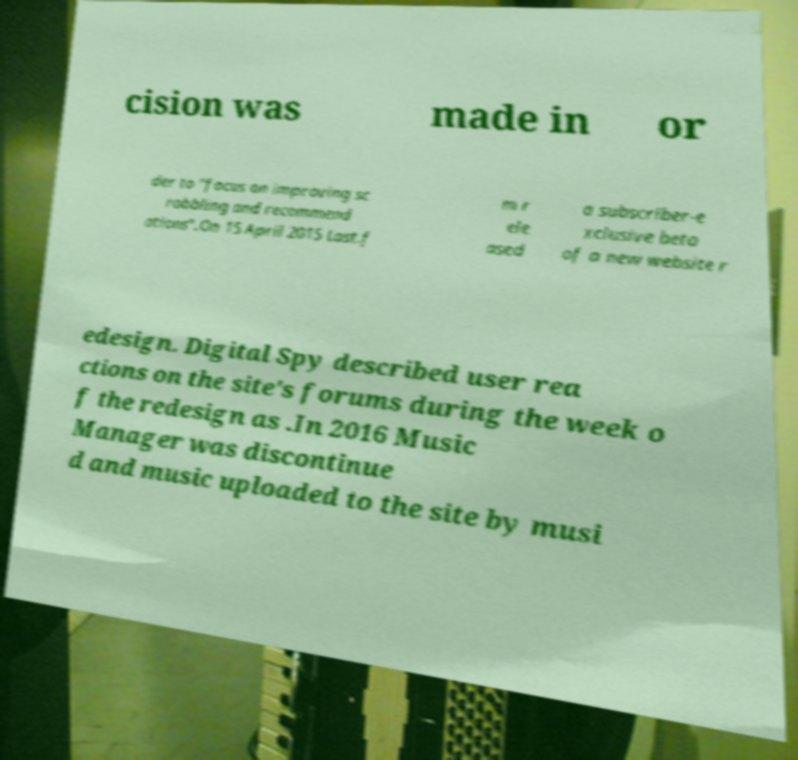Can you accurately transcribe the text from the provided image for me? cision was made in or der to "focus on improving sc robbling and recommend ations".On 15 April 2015 Last.f m r ele ased a subscriber-e xclusive beta of a new website r edesign. Digital Spy described user rea ctions on the site's forums during the week o f the redesign as .In 2016 Music Manager was discontinue d and music uploaded to the site by musi 